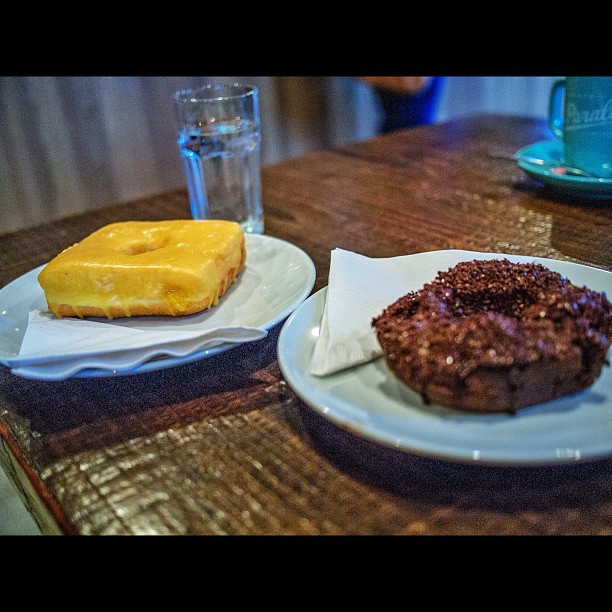<image>Which one has the fewest marshmallows? I don't know which one has the fewest marshmallows. It could be the left or right one, or neither. Which one has the fewest marshmallows? I don't know which one has the fewest marshmallows. It could be neither, both, or one of the sides. 